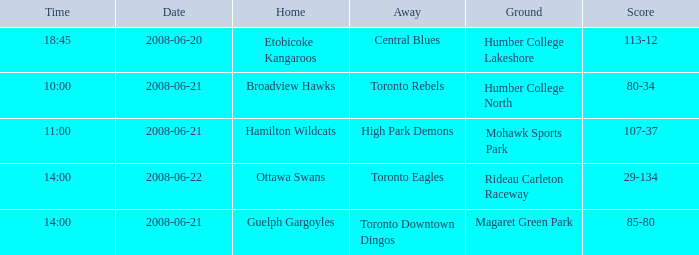What is the Away with a Ground that is humber college north? Toronto Rebels. 